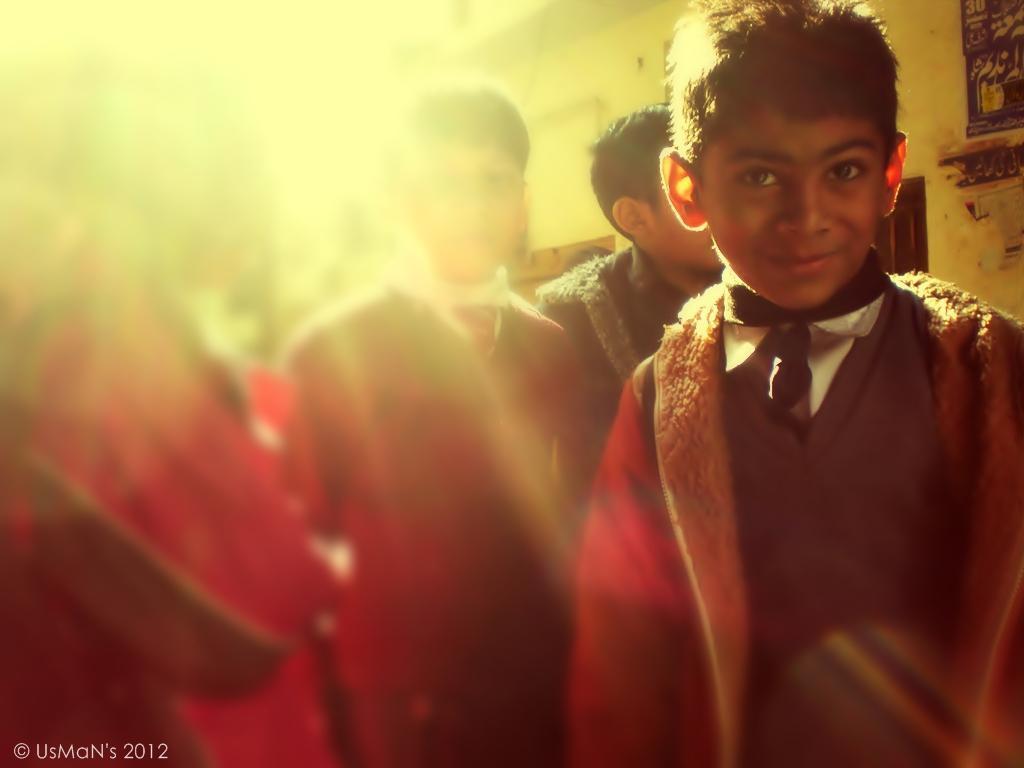In one or two sentences, can you explain what this image depicts? In this image there are persons standing. On the right side there is a wall and there are objects which are visible. On the bottom left of the image there is some text and there are numbers. 